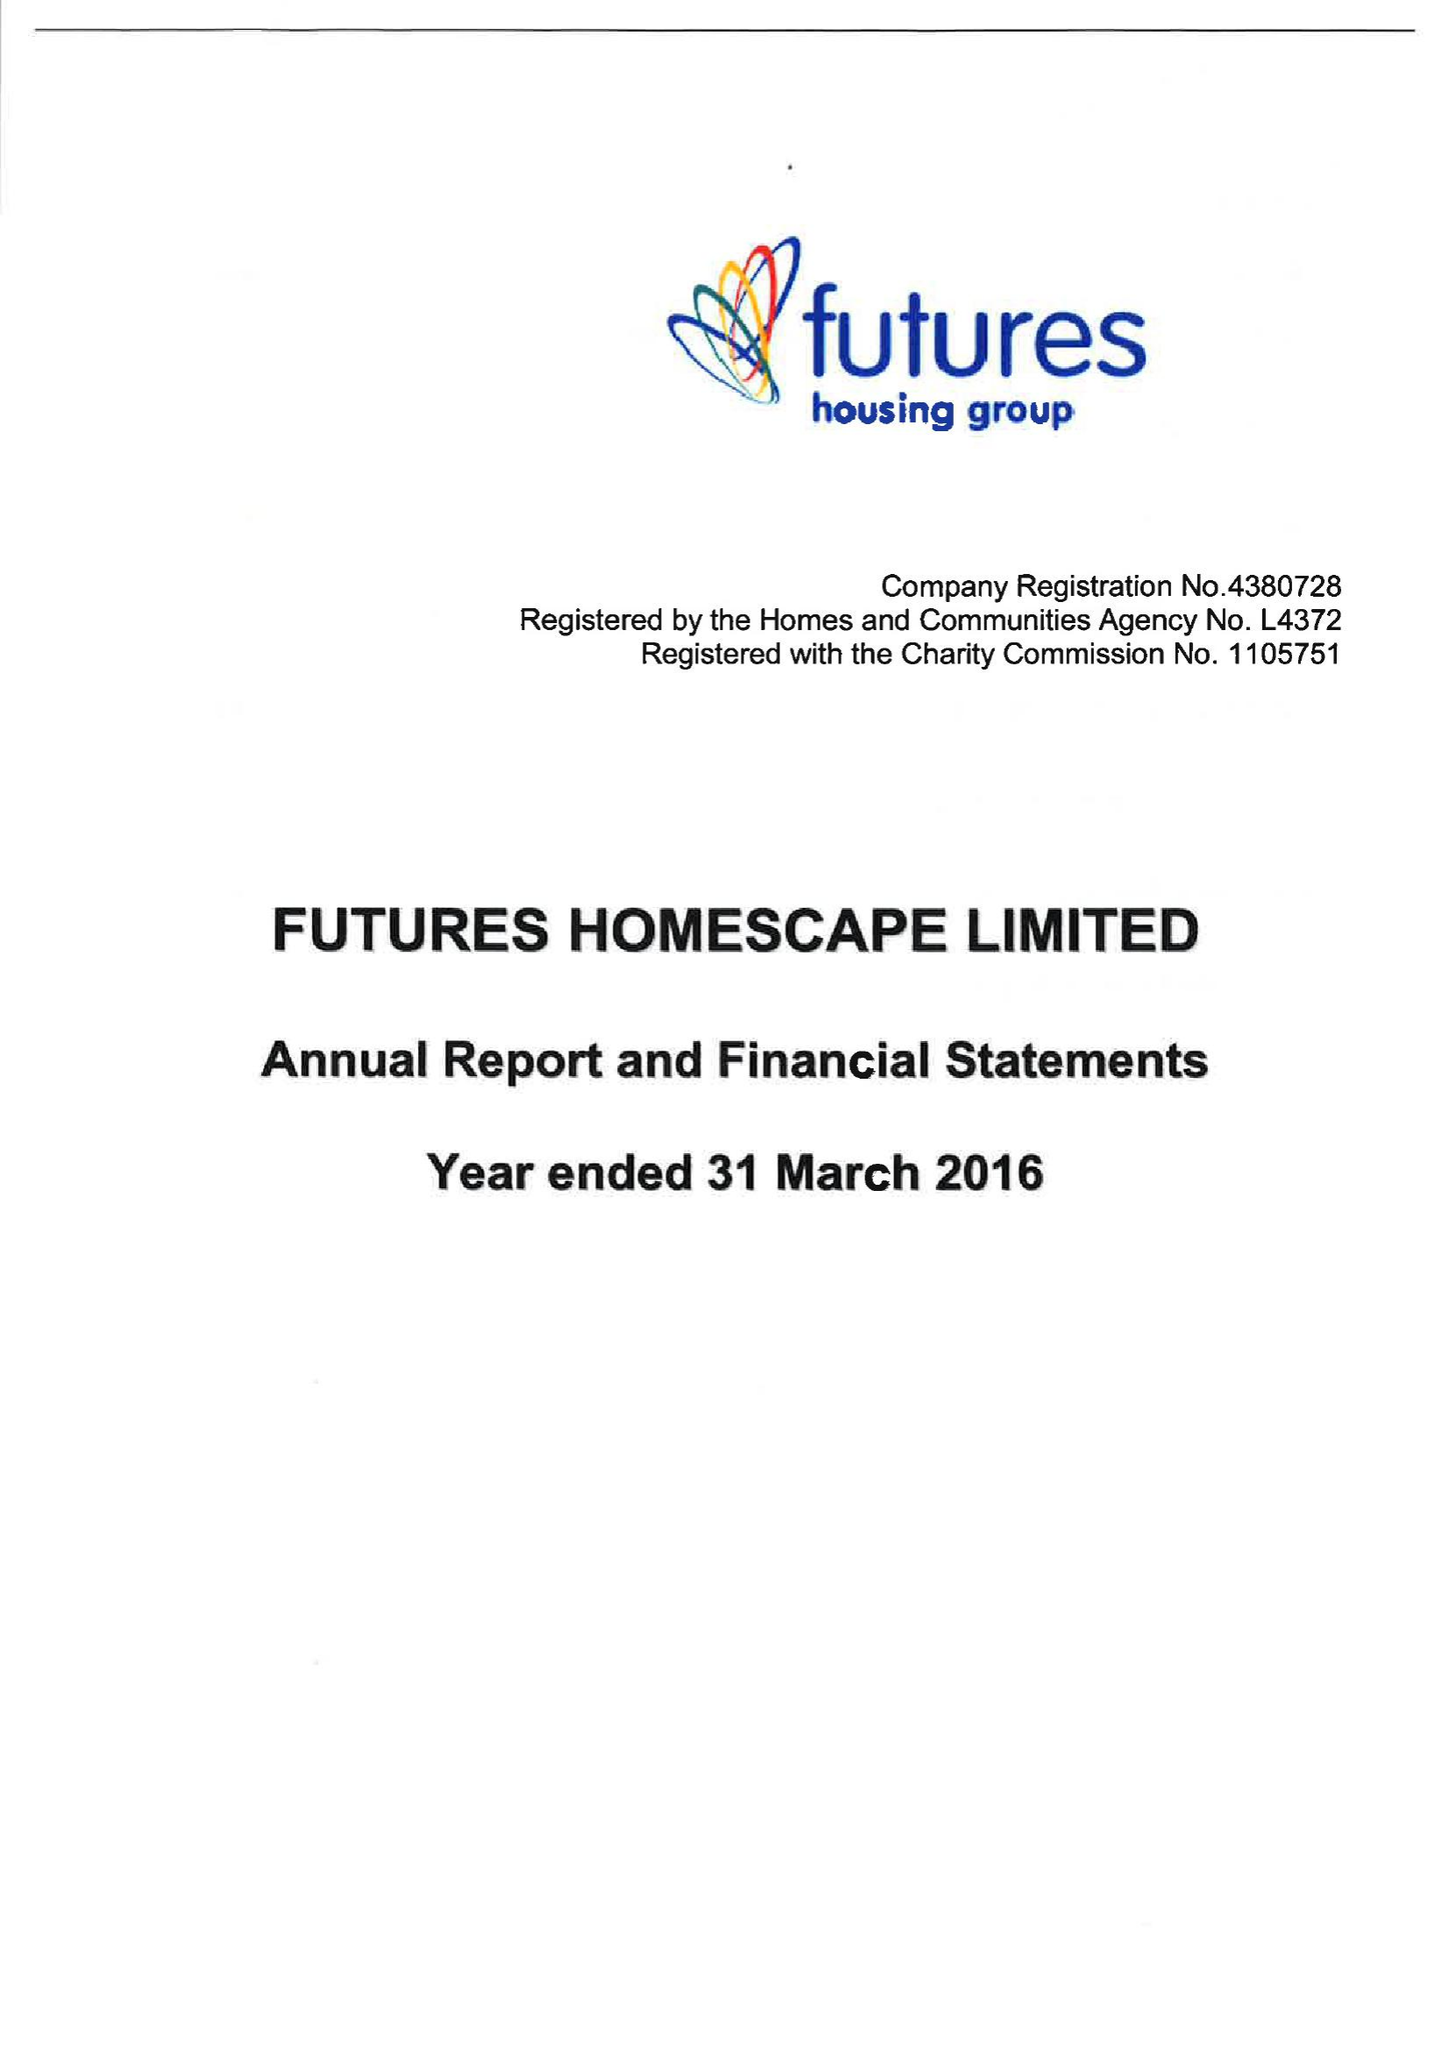What is the value for the charity_number?
Answer the question using a single word or phrase. 1105751 